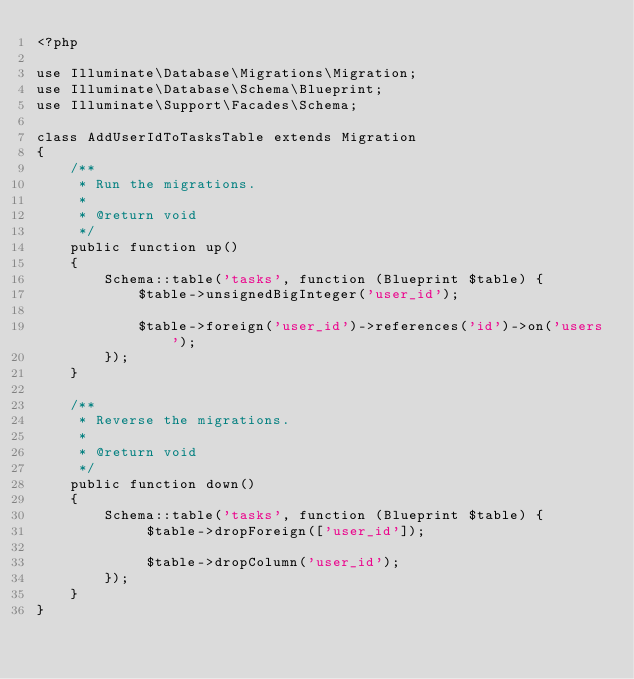<code> <loc_0><loc_0><loc_500><loc_500><_PHP_><?php

use Illuminate\Database\Migrations\Migration;
use Illuminate\Database\Schema\Blueprint;
use Illuminate\Support\Facades\Schema;

class AddUserIdToTasksTable extends Migration
{
    /**
     * Run the migrations.
     *
     * @return void
     */
    public function up()
    {
        Schema::table('tasks', function (Blueprint $table) {
            $table->unsignedBigInteger('user_id');
            
            $table->foreign('user_id')->references('id')->on('users');
        });
    }

    /**
     * Reverse the migrations.
     *
     * @return void
     */
    public function down()
    {
        Schema::table('tasks', function (Blueprint $table) {
             $table->dropForeign(['user_id']);
             
             $table->dropColumn('user_id');
        });
    }
}
</code> 